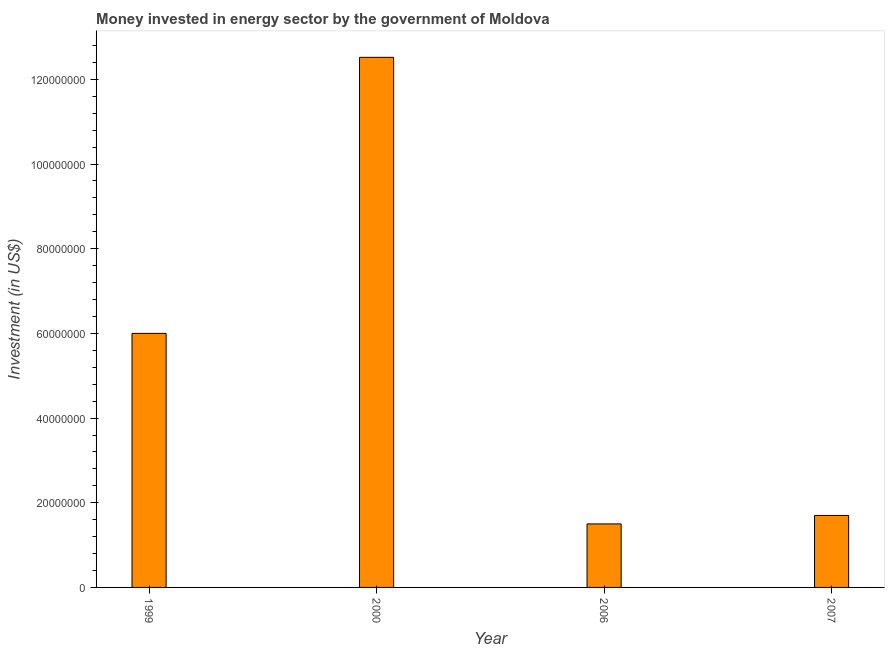What is the title of the graph?
Ensure brevity in your answer.  Money invested in energy sector by the government of Moldova. What is the label or title of the Y-axis?
Provide a succinct answer. Investment (in US$). What is the investment in energy in 2007?
Keep it short and to the point. 1.70e+07. Across all years, what is the maximum investment in energy?
Offer a terse response. 1.25e+08. Across all years, what is the minimum investment in energy?
Offer a very short reply. 1.50e+07. In which year was the investment in energy minimum?
Keep it short and to the point. 2006. What is the sum of the investment in energy?
Keep it short and to the point. 2.17e+08. What is the difference between the investment in energy in 1999 and 2007?
Your answer should be compact. 4.30e+07. What is the average investment in energy per year?
Your answer should be very brief. 5.43e+07. What is the median investment in energy?
Make the answer very short. 3.85e+07. Do a majority of the years between 1999 and 2007 (inclusive) have investment in energy greater than 24000000 US$?
Your answer should be compact. No. What is the ratio of the investment in energy in 2000 to that in 2006?
Your answer should be compact. 8.35. What is the difference between the highest and the second highest investment in energy?
Offer a very short reply. 6.52e+07. Is the sum of the investment in energy in 1999 and 2006 greater than the maximum investment in energy across all years?
Provide a succinct answer. No. What is the difference between the highest and the lowest investment in energy?
Offer a terse response. 1.10e+08. Are all the bars in the graph horizontal?
Your answer should be compact. No. How many years are there in the graph?
Your answer should be very brief. 4. Are the values on the major ticks of Y-axis written in scientific E-notation?
Your answer should be compact. No. What is the Investment (in US$) in 1999?
Offer a terse response. 6.00e+07. What is the Investment (in US$) in 2000?
Provide a succinct answer. 1.25e+08. What is the Investment (in US$) in 2006?
Offer a terse response. 1.50e+07. What is the Investment (in US$) in 2007?
Ensure brevity in your answer.  1.70e+07. What is the difference between the Investment (in US$) in 1999 and 2000?
Your answer should be very brief. -6.52e+07. What is the difference between the Investment (in US$) in 1999 and 2006?
Offer a very short reply. 4.50e+07. What is the difference between the Investment (in US$) in 1999 and 2007?
Your response must be concise. 4.30e+07. What is the difference between the Investment (in US$) in 2000 and 2006?
Ensure brevity in your answer.  1.10e+08. What is the difference between the Investment (in US$) in 2000 and 2007?
Your response must be concise. 1.08e+08. What is the ratio of the Investment (in US$) in 1999 to that in 2000?
Give a very brief answer. 0.48. What is the ratio of the Investment (in US$) in 1999 to that in 2007?
Keep it short and to the point. 3.53. What is the ratio of the Investment (in US$) in 2000 to that in 2006?
Offer a very short reply. 8.35. What is the ratio of the Investment (in US$) in 2000 to that in 2007?
Your answer should be compact. 7.37. What is the ratio of the Investment (in US$) in 2006 to that in 2007?
Give a very brief answer. 0.88. 